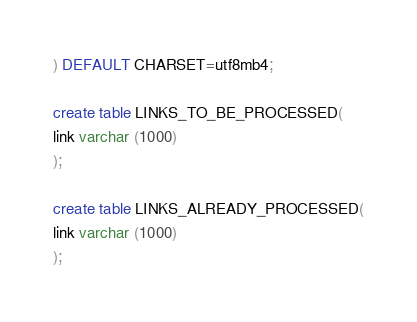Convert code to text. <code><loc_0><loc_0><loc_500><loc_500><_SQL_>) DEFAULT CHARSET=utf8mb4;

create table LINKS_TO_BE_PROCESSED(
link varchar (1000)
);

create table LINKS_ALREADY_PROCESSED(
link varchar (1000)
);</code> 